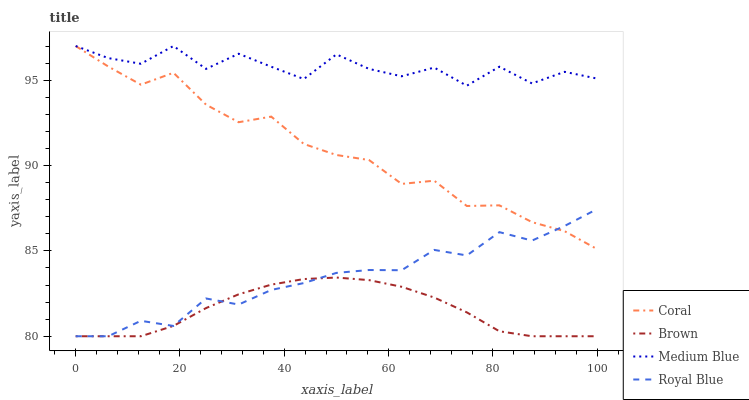Does Brown have the minimum area under the curve?
Answer yes or no. Yes. Does Medium Blue have the maximum area under the curve?
Answer yes or no. Yes. Does Coral have the minimum area under the curve?
Answer yes or no. No. Does Coral have the maximum area under the curve?
Answer yes or no. No. Is Brown the smoothest?
Answer yes or no. Yes. Is Medium Blue the roughest?
Answer yes or no. Yes. Is Coral the smoothest?
Answer yes or no. No. Is Coral the roughest?
Answer yes or no. No. Does Coral have the lowest value?
Answer yes or no. No. Does Royal Blue have the highest value?
Answer yes or no. No. Is Brown less than Coral?
Answer yes or no. Yes. Is Medium Blue greater than Brown?
Answer yes or no. Yes. Does Brown intersect Coral?
Answer yes or no. No. 